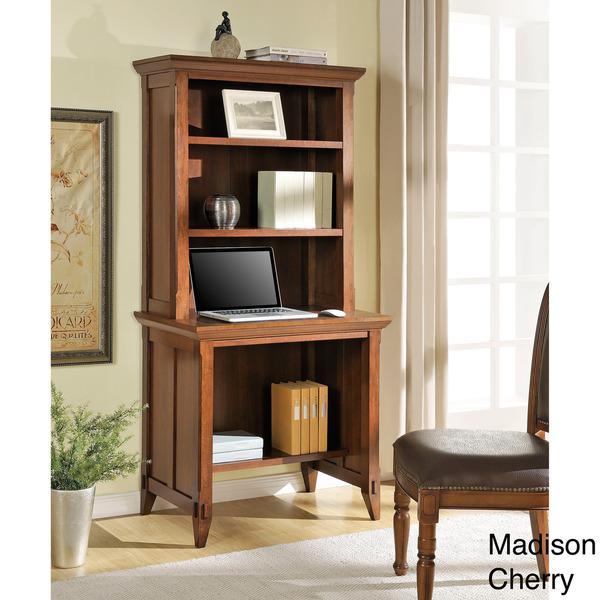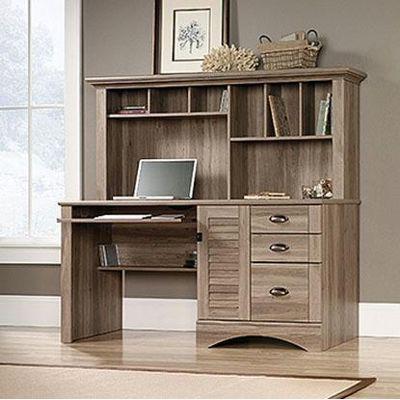The first image is the image on the left, the second image is the image on the right. Evaluate the accuracy of this statement regarding the images: "There is a chair in front of one of the office units.". Is it true? Answer yes or no. Yes. 